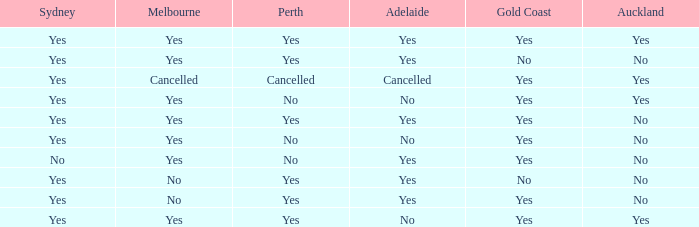What is The Melbourne with a No- Gold Coast Yes, No. 